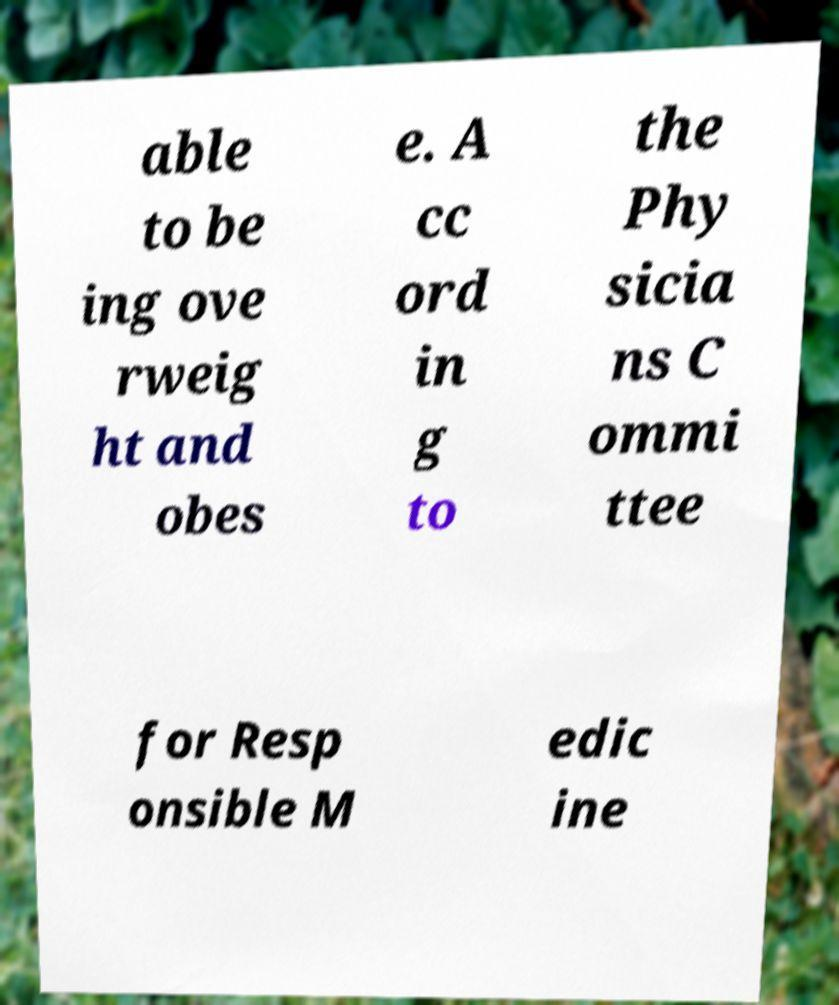I need the written content from this picture converted into text. Can you do that? able to be ing ove rweig ht and obes e. A cc ord in g to the Phy sicia ns C ommi ttee for Resp onsible M edic ine 